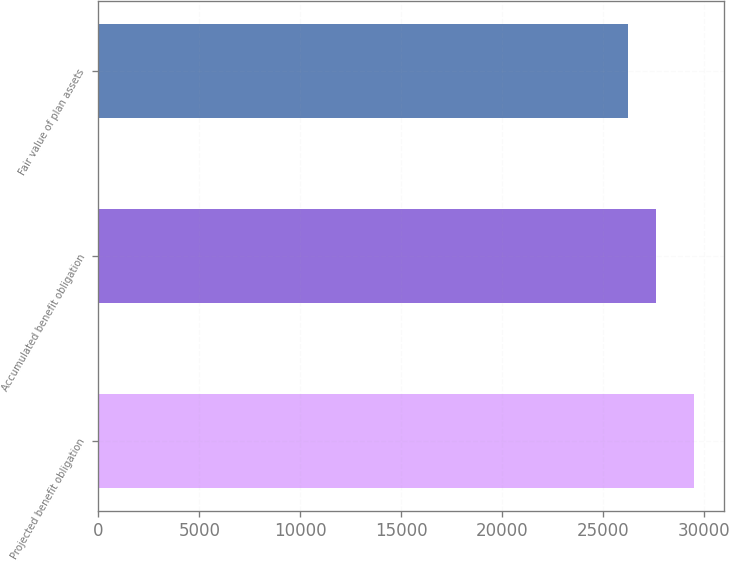Convert chart. <chart><loc_0><loc_0><loc_500><loc_500><bar_chart><fcel>Projected benefit obligation<fcel>Accumulated benefit obligation<fcel>Fair value of plan assets<nl><fcel>29508<fcel>27623<fcel>26224<nl></chart> 